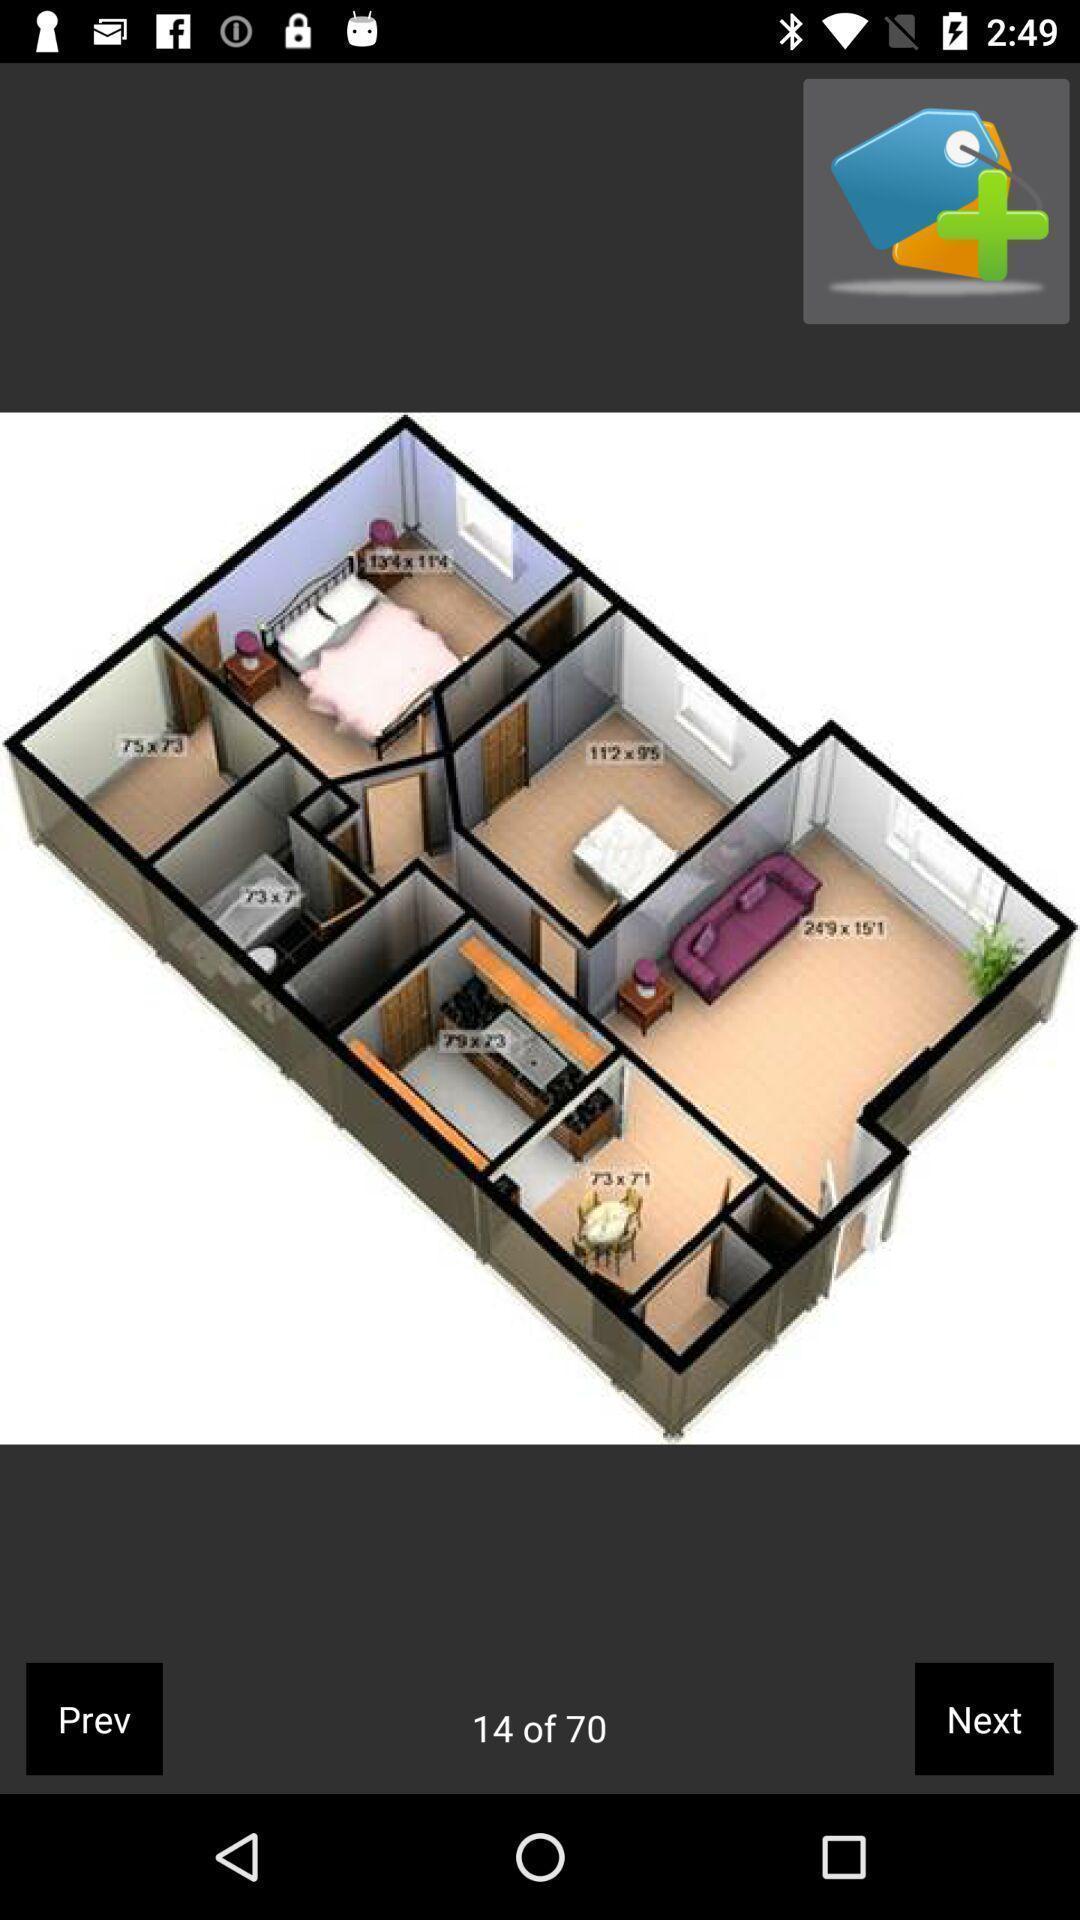Describe the content in this image. Page showing image of an interior. 